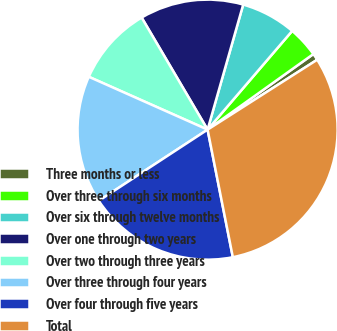Convert chart to OTSL. <chart><loc_0><loc_0><loc_500><loc_500><pie_chart><fcel>Three months or less<fcel>Over three through six months<fcel>Over six through twelve months<fcel>Over one through two years<fcel>Over two through three years<fcel>Over three through four years<fcel>Over four through five years<fcel>Total<nl><fcel>0.84%<fcel>3.85%<fcel>6.86%<fcel>12.88%<fcel>9.87%<fcel>15.88%<fcel>18.89%<fcel>30.92%<nl></chart> 